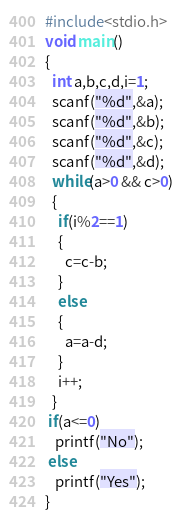<code> <loc_0><loc_0><loc_500><loc_500><_C_>#include<stdio.h>
void main()
{
  int a,b,c,d,i=1;
  scanf("%d",&a);
  scanf("%d",&b);
  scanf("%d",&c);
  scanf("%d",&d);
  while(a>0 && c>0)
  {
    if(i%2==1)
    {
      c=c-b;
    }
    else
    {
      a=a-d;
    }
    i++;
  }
 if(a<=0)
   printf("No");
 else
   printf("Yes");
}</code> 